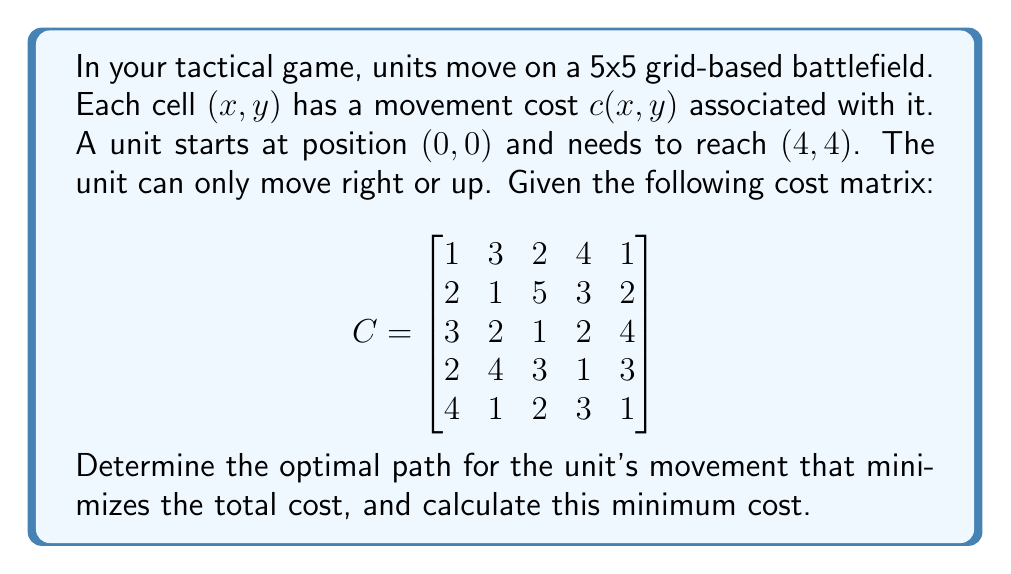Give your solution to this math problem. To solve this problem, we can use dynamic programming, specifically the principle of optimality. We'll create a matrix $D$ where $D(i,j)$ represents the minimum cost to reach cell $(i,j)$ from $(0,0)$.

1) Initialize the first row and column of $D$:
   $D(0,0) = C(0,0) = 1$
   For $i > 0$: $D(i,0) = D(i-1,0) + C(i,0)$
   For $j > 0$: $D(0,j) = D(0,j-1) + C(0,j)$

2) Fill the rest of $D$ using the recurrence relation:
   $D(i,j) = \min(D(i-1,j), D(i,j-1)) + C(i,j)$

3) The resulting $D$ matrix:

$$
D = \begin{bmatrix}
1 & 4 & 6 & 10 & 11 \\
3 & 4 & 9 & 12 & 13 \\
6 & 6 & 7 & 9 & 13 \\
8 & 10 & 10 & 10 & 13 \\
12 & 11 & 12 & 13 & 14
\end{bmatrix}
$$

4) The minimum cost to reach $(4,4)$ is $D(4,4) = 14$.

5) To find the optimal path, we backtrack from $(4,4)$ to $(0,0)$:
   - Start at $(4,4)$
   - Compare $D(3,4)$ and $D(4,3)$. $D(3,4) = 13 < D(4,3) = 13$, so move up to $(3,4)$
   - Compare $D(2,4)$ and $D(3,3)$. $D(3,3) = 10 < D(2,4) = 13$, so move left to $(3,3)$
   - Compare $D(2,3)$ and $D(3,2)$. $D(2,3) = 9 < D(3,2) = 10$, so move up to $(2,3)$
   - Compare $D(1,3)$ and $D(2,2)$. $D(2,2) = 6 < D(1,3) = 12$, so move left to $(2,2)$
   - Compare $D(1,2)$ and $D(2,1)$. $D(1,2) = 4 < D(2,1) = 6$, so move up to $(1,2)$
   - Compare $D(0,2)$ and $D(1,1)$. $D(0,2) = 6 > D(1,1) = 4$, so move left to $(1,1)$
   - Compare $D(0,1)$ and $D(1,0)$. $D(0,1) = 4 > D(1,0) = 3$, so move up to $(1,0)$
   - Finally, move to $(0,0)$

Therefore, the optimal path is: $(0,0) \rightarrow (1,0) \rightarrow (1,1) \rightarrow (1,2) \rightarrow (2,2) \rightarrow (2,3) \rightarrow (3,3) \rightarrow (3,4) \rightarrow (4,4)$
Answer: The optimal path is $(0,0) \rightarrow (1,0) \rightarrow (1,1) \rightarrow (1,2) \rightarrow (2,2) \rightarrow (2,3) \rightarrow (3,3) \rightarrow (3,4) \rightarrow (4,4)$ with a minimum total cost of 14. 